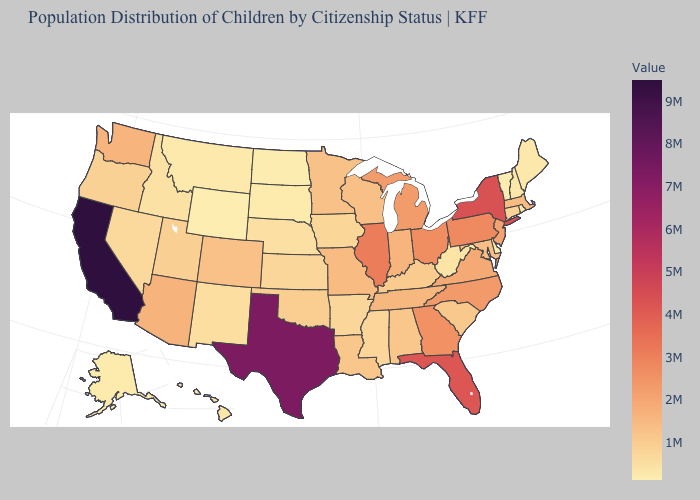Does California have the highest value in the West?
Be succinct. Yes. Does the map have missing data?
Keep it brief. No. Among the states that border Missouri , does Tennessee have the lowest value?
Quick response, please. No. Which states have the lowest value in the USA?
Quick response, please. Vermont. Among the states that border Wisconsin , which have the lowest value?
Give a very brief answer. Iowa. Is the legend a continuous bar?
Be succinct. Yes. Which states have the lowest value in the USA?
Concise answer only. Vermont. Does Illinois have the highest value in the MidWest?
Be succinct. Yes. 